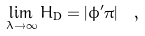Convert formula to latex. <formula><loc_0><loc_0><loc_500><loc_500>\lim _ { \lambda \rightarrow \infty } H _ { \text {D} } = \left | \phi ^ { \prime } \pi \right | \ ,</formula> 